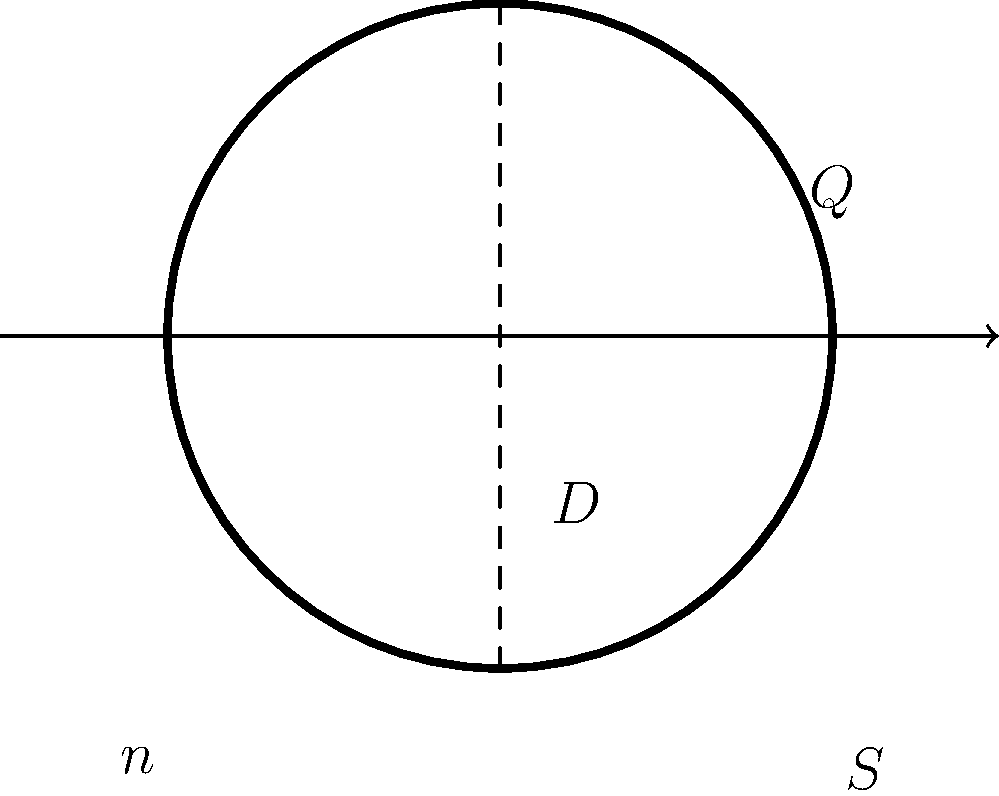As an educational technology expert integrating virtual reality in engineering education, you're designing a simulation for civil engineering students. The simulation involves analyzing water flow through a circular pipe using Manning's equation. Given a circular pipe with a diameter of 0.6 meters, a Manning's roughness coefficient (n) of 0.013, and a slope (S) of 0.002, calculate the flow rate (Q) in cubic meters per second. Use Manning's equation: $Q = \frac{1}{n} A R^{\frac{2}{3}} S^{\frac{1}{2}}$, where A is the cross-sectional area and R is the hydraulic radius. To solve this problem, we'll follow these steps:

1) Calculate the cross-sectional area (A):
   $A = \pi r^2 = \pi (\frac{D}{2})^2 = \pi (\frac{0.6}{2})^2 = 0.2827 \text{ m}^2$

2) Calculate the wetted perimeter (P):
   $P = \pi D = \pi (0.6) = 1.8850 \text{ m}$

3) Calculate the hydraulic radius (R):
   $R = \frac{A}{P} = \frac{0.2827}{1.8850} = 0.1500 \text{ m}$

4) Apply Manning's equation:
   $Q = \frac{1}{n} A R^{\frac{2}{3}} S^{\frac{1}{2}}$

   $Q = \frac{1}{0.013} (0.2827) (0.1500)^{\frac{2}{3}} (0.002)^{\frac{1}{2}}$

5) Calculate the result:
   $Q = 76.92 \times 0.2827 \times 0.2874 \times 0.0447 = 0.2789 \text{ m}^3/\text{s}$

Therefore, the flow rate through the pipe is approximately 0.2789 cubic meters per second.
Answer: $0.2789 \text{ m}^3/\text{s}$ 